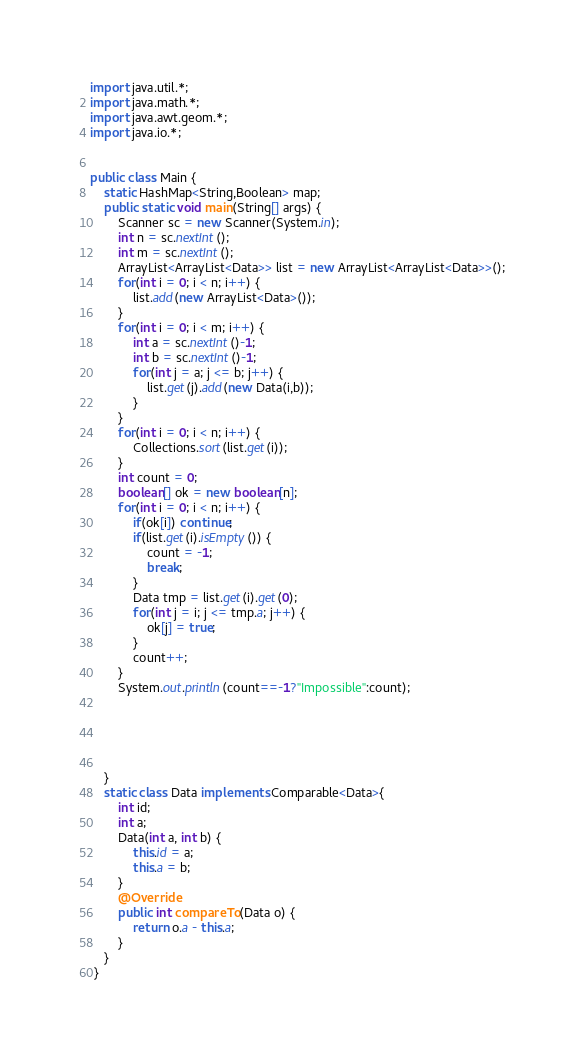Convert code to text. <code><loc_0><loc_0><loc_500><loc_500><_Java_>import java.util.*;
import java.math.*;
import java.awt.geom.*;
import java.io.*;
      
      
public class Main {
	static HashMap<String,Boolean> map;
	public static void main(String[] args) {
		Scanner sc = new Scanner(System.in);
		int n = sc.nextInt();
		int m = sc.nextInt();
		ArrayList<ArrayList<Data>> list = new ArrayList<ArrayList<Data>>();
		for(int i = 0; i < n; i++) {
			list.add(new ArrayList<Data>());
		}
		for(int i = 0; i < m; i++) {
			int a = sc.nextInt()-1;
			int b = sc.nextInt()-1;
			for(int j = a; j <= b; j++) {
				list.get(j).add(new Data(i,b));
			}
		}
		for(int i = 0; i < n; i++) {
			Collections.sort(list.get(i));
		}
		int count = 0;
		boolean[] ok = new boolean[n];
		for(int i = 0; i < n; i++) {
			if(ok[i]) continue;
			if(list.get(i).isEmpty()) {
				count = -1;
				break;
			}
			Data tmp = list.get(i).get(0);
			for(int j = i; j <= tmp.a; j++) {
				ok[j] = true;
			}
			count++;
		}
		System.out.println(count==-1?"Impossible":count);
		
		
		
		
		
	}
	static class Data implements Comparable<Data>{
		int id;
		int a;
		Data(int a, int b) {
			this.id = a;
			this.a = b; 
		}
		@Override
		public int compareTo(Data o) {
			return o.a - this.a;
		}
	}
 }</code> 